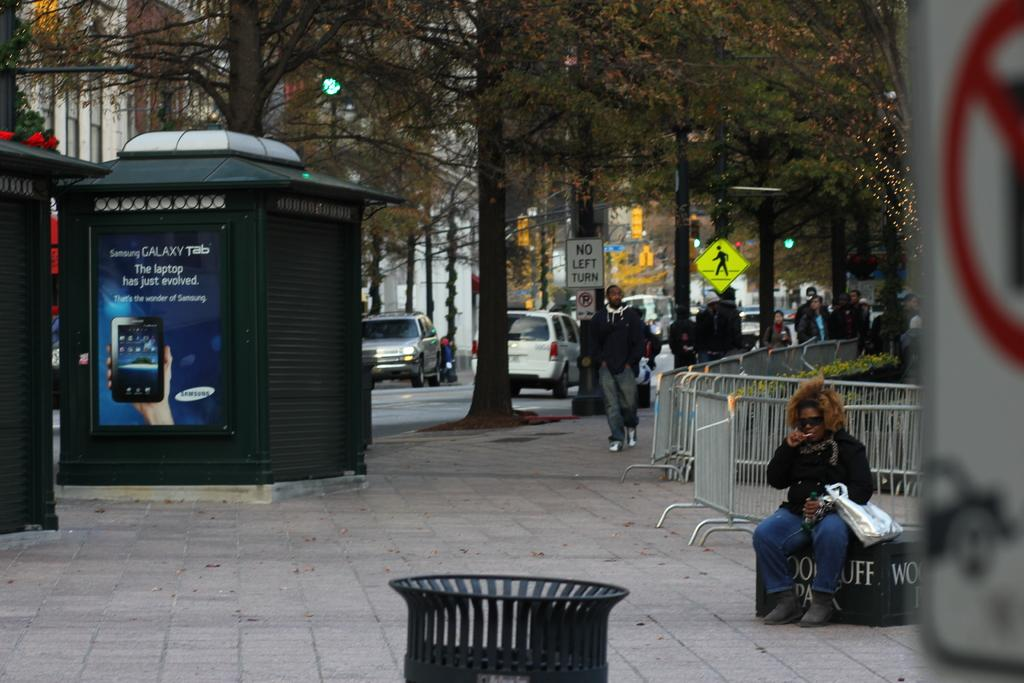<image>
Provide a brief description of the given image. A Street scene with an ad for the Samsung Galaxy tab. 